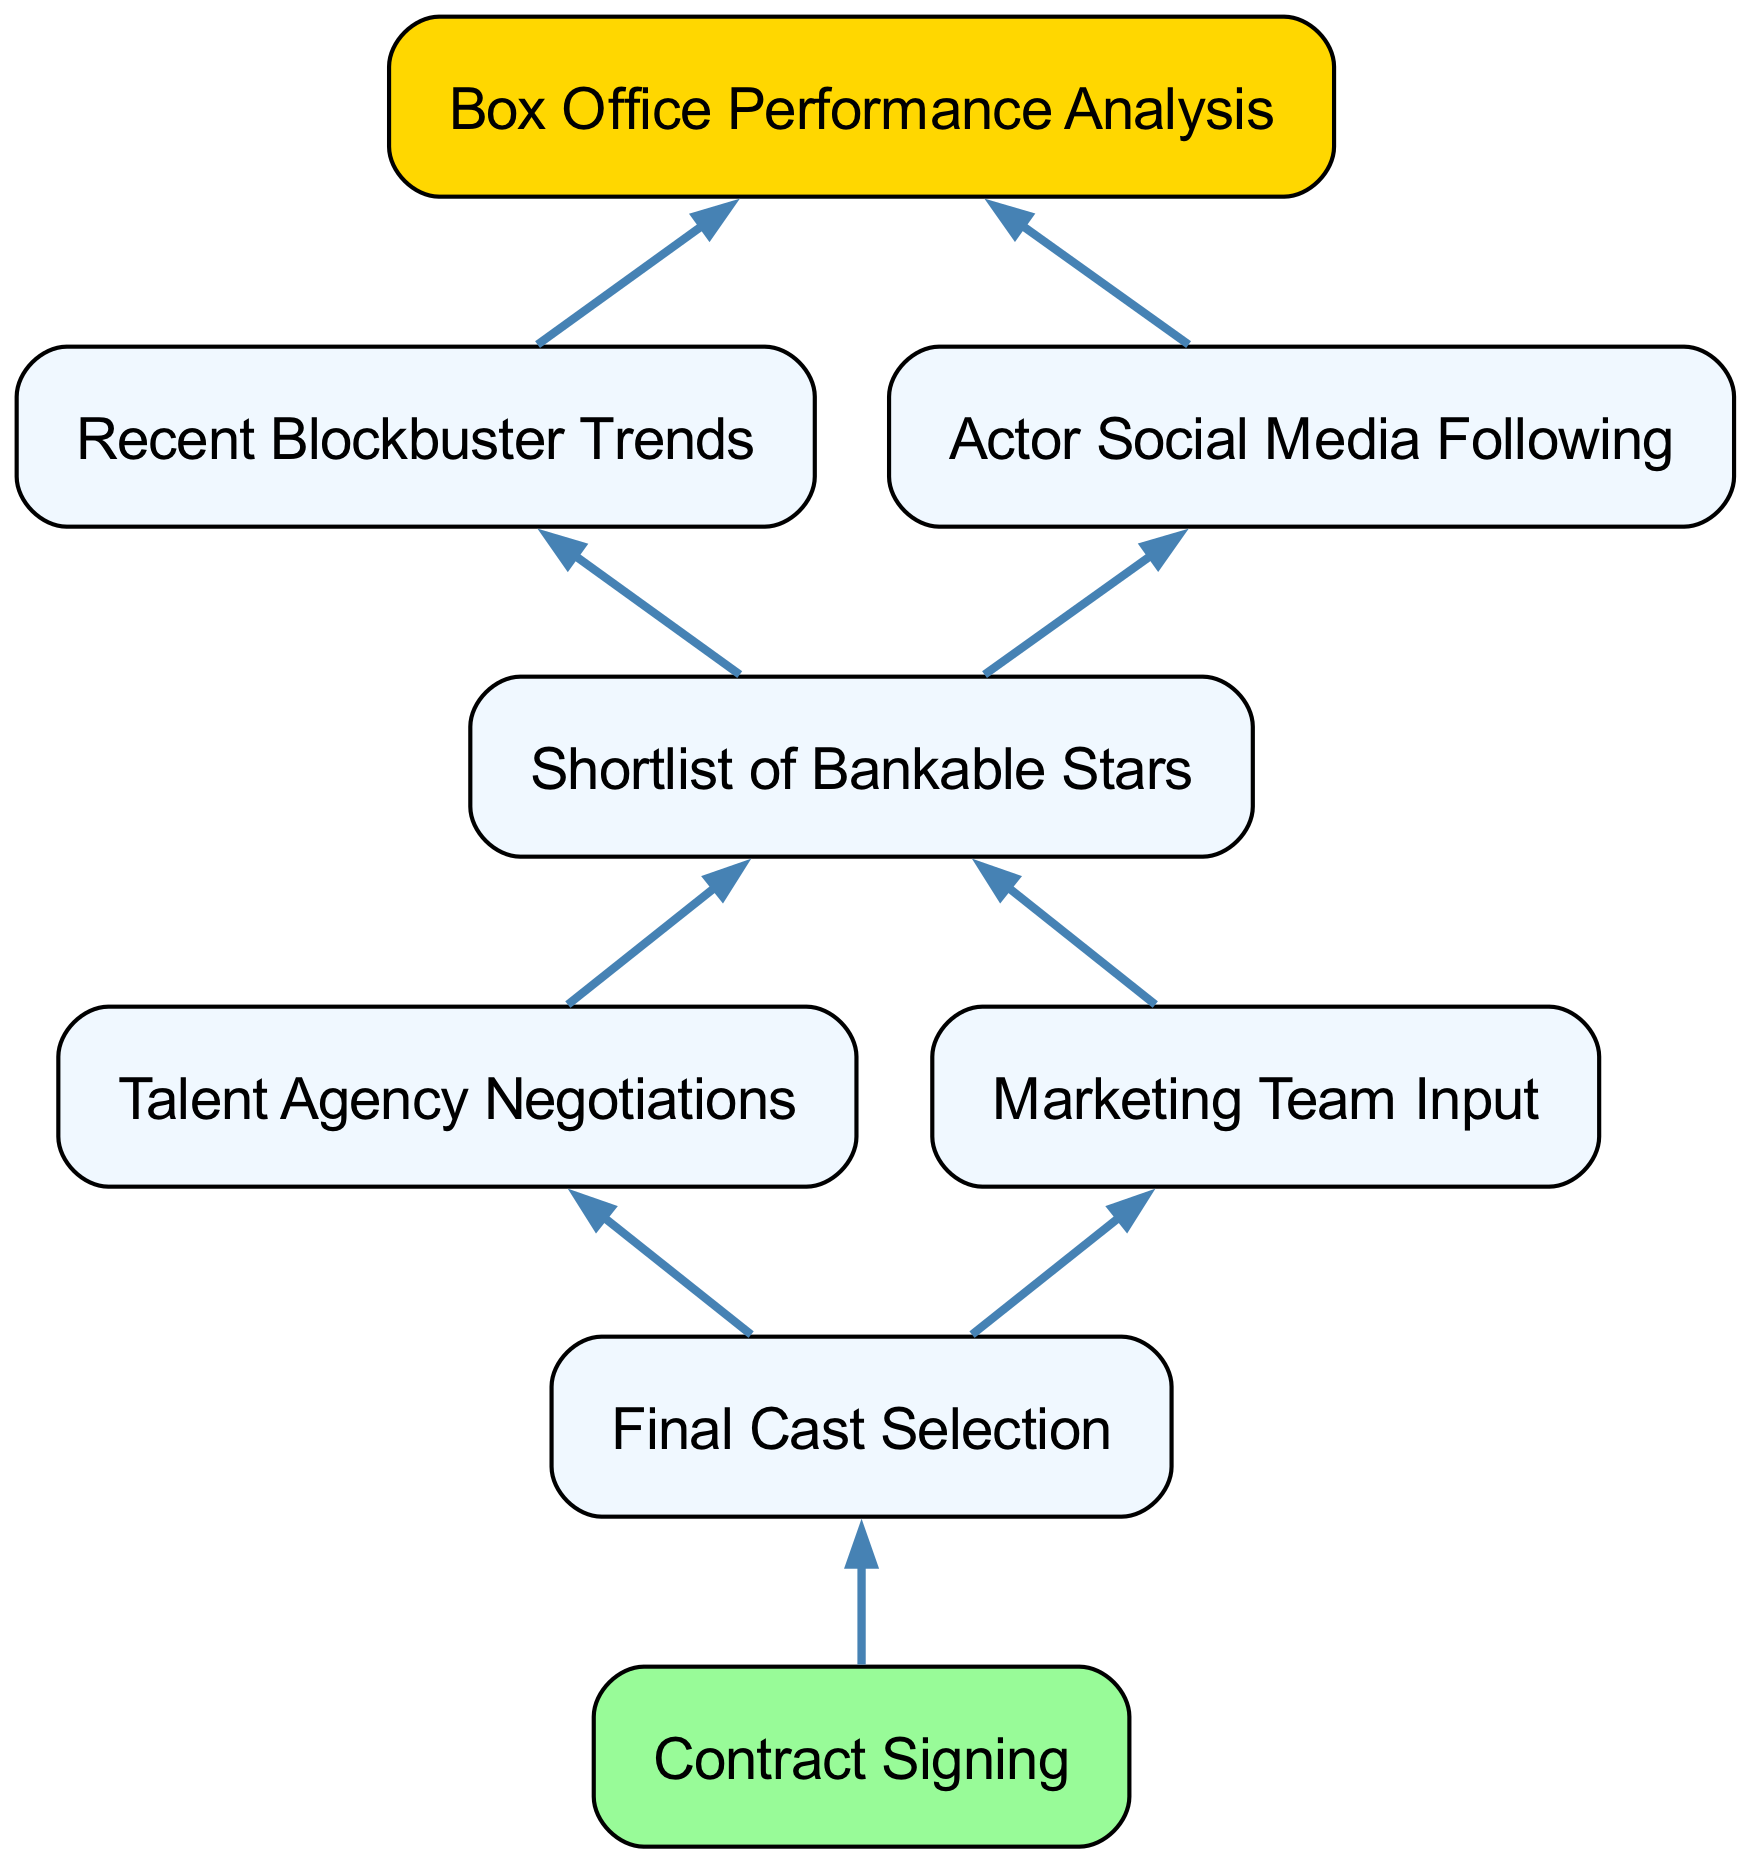What is the root node of the diagram? The root node, which is the starting point of the flowchart, is labeled "Box Office Performance Analysis." There is only one root node in a bottom-up flow chart, which connects to the subsequent layers of information.
Answer: Box Office Performance Analysis How many children does "Box Office Performance Analysis" have? The node "Box Office Performance Analysis" has two children, which are "Recent Blockbuster Trends" and "Actor Social Media Following." This is determined by counting the elements listed as children under that node.
Answer: 2 What are the two types of analysis leading to the shortlist of stars? The two analyses that lead to the shortlist of bankable stars are "Recent Blockbuster Trends" and "Actor Social Media Following." These analyses provide insight into which actors might be valuable based on current trends and audience engagement.
Answer: Recent Blockbuster Trends and Actor Social Media Following What is the final step in the cast selection process? The final step in the cast selection process is "Contract Signing." This is the end point of the flow chart where the selected actors finalize their agreements to join the project.
Answer: Contract Signing What node comes immediately after "Marketing Team Input"? The node that comes immediately after "Marketing Team Input" is "Final Cast Selection." This indicates a flow where input from the marketing team informs the final decision on casting.
Answer: Final Cast Selection What is the relationship between "Talent Agency Negotiations" and "Final Cast Selection"? The relationship is that "Talent Agency Negotiations" is a child node of "Shortlist of Bankable Stars" and leads into "Final Cast Selection." This indicates that negotiations with talent agencies are part of the process before finalizing the cast.
Answer: Leads into Which node is associated with the color light green? The node associated with the color light green is "Contract Signing." In the diagram, specific nodes can be stylized with different colors, and light green indicates that this node is the final stage of the process.
Answer: Contract Signing How many total nodes are present in the diagram? There are a total of eight nodes in the diagram, counting every unique element from the root to the final step. This includes all main nodes and their children throughout the process.
Answer: 8 What is necessary before "Final Cast Selection" can occur? Before "Final Cast Selection" can occur, both "Talent Agency Negotiations" and "Marketing Team Input" must take place. These steps are necessary to ensure that all relevant factors are considered before making the final casting decision.
Answer: Both negotiations and input from marketing are necessary 